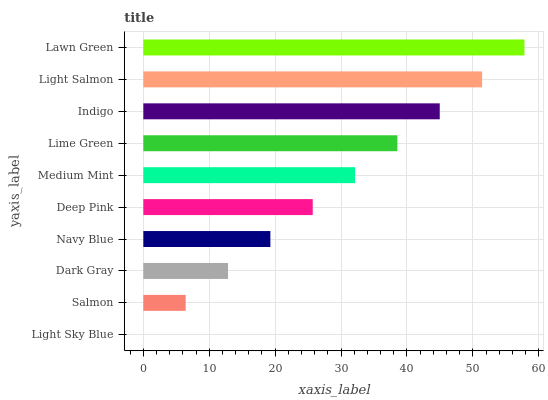Is Light Sky Blue the minimum?
Answer yes or no. Yes. Is Lawn Green the maximum?
Answer yes or no. Yes. Is Salmon the minimum?
Answer yes or no. No. Is Salmon the maximum?
Answer yes or no. No. Is Salmon greater than Light Sky Blue?
Answer yes or no. Yes. Is Light Sky Blue less than Salmon?
Answer yes or no. Yes. Is Light Sky Blue greater than Salmon?
Answer yes or no. No. Is Salmon less than Light Sky Blue?
Answer yes or no. No. Is Medium Mint the high median?
Answer yes or no. Yes. Is Deep Pink the low median?
Answer yes or no. Yes. Is Deep Pink the high median?
Answer yes or no. No. Is Indigo the low median?
Answer yes or no. No. 